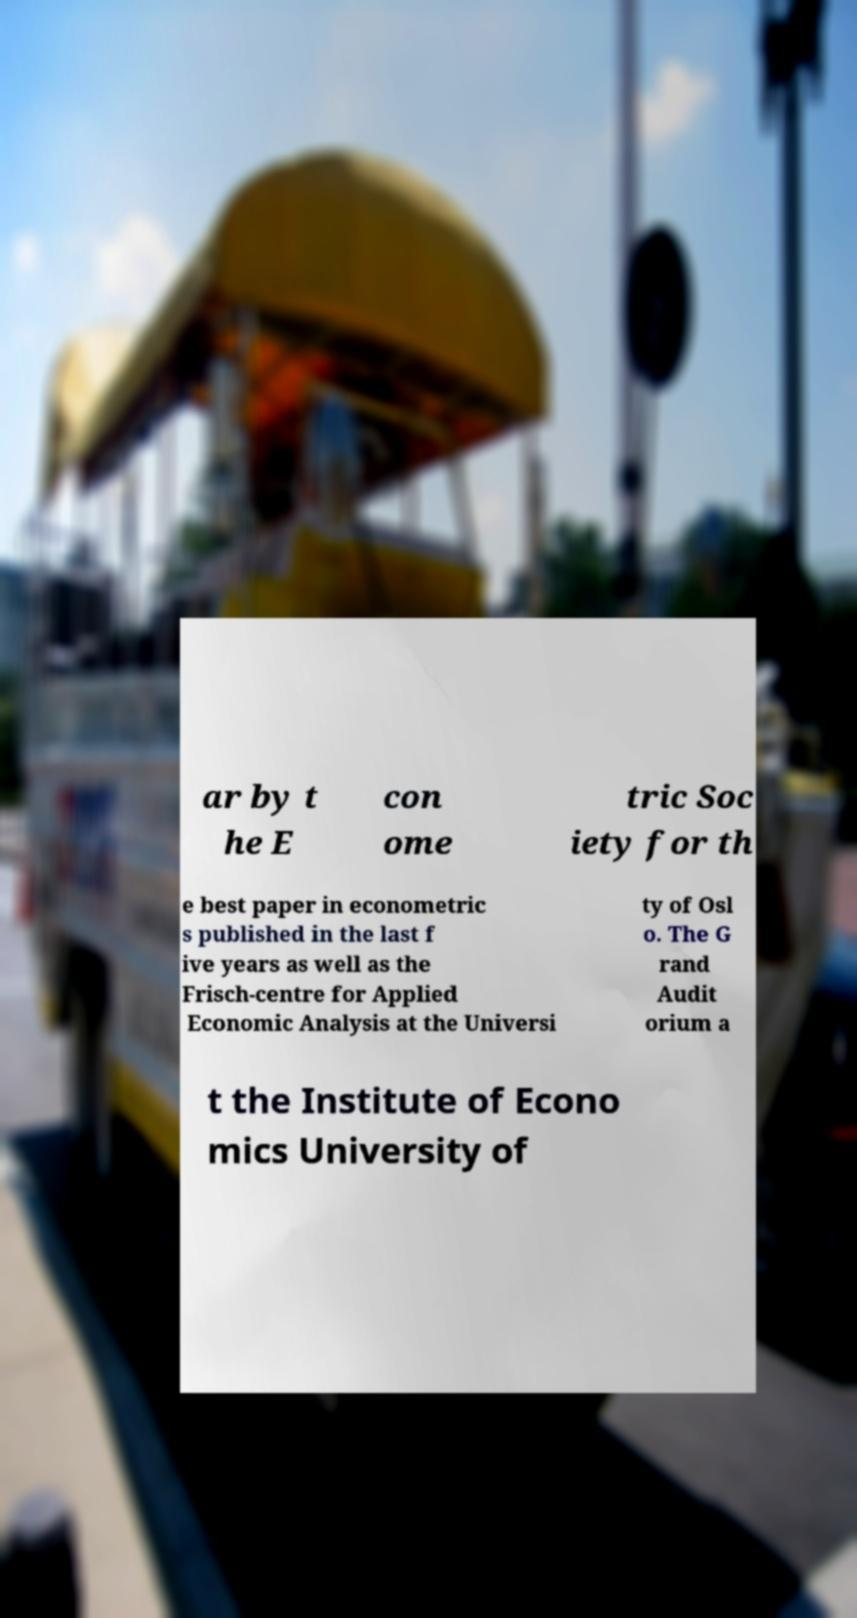Could you assist in decoding the text presented in this image and type it out clearly? ar by t he E con ome tric Soc iety for th e best paper in econometric s published in the last f ive years as well as the Frisch-centre for Applied Economic Analysis at the Universi ty of Osl o. The G rand Audit orium a t the Institute of Econo mics University of 